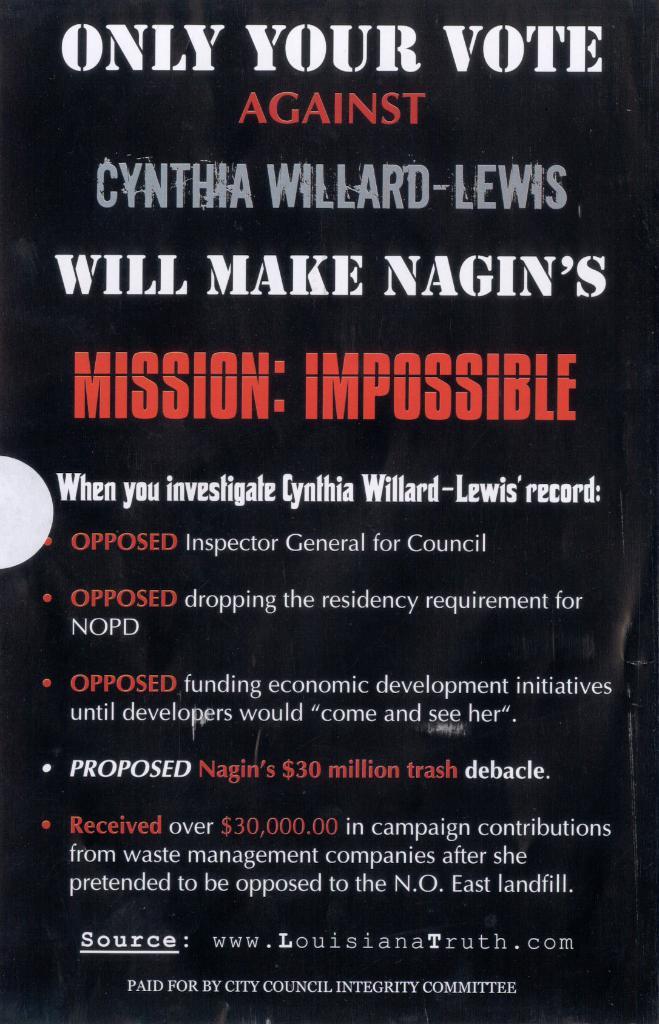Who received over 30,000,000 in contributions from waste management companies?
Give a very brief answer. Cynthia willard-lewis. Who paid for this ad?
Give a very brief answer. City council integrity committee. 